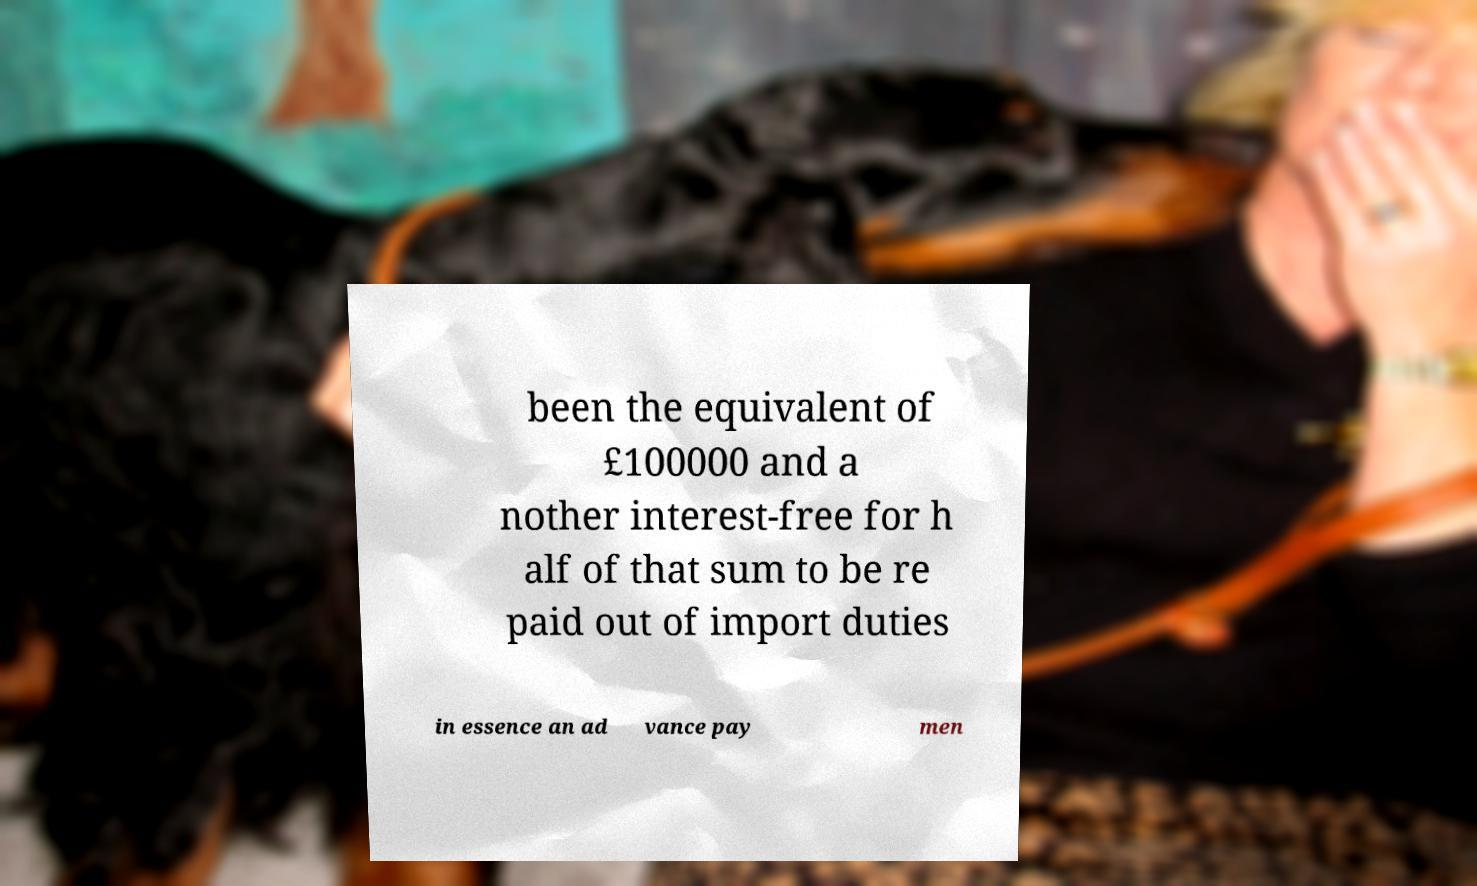Can you accurately transcribe the text from the provided image for me? been the equivalent of £100000 and a nother interest-free for h alf of that sum to be re paid out of import duties in essence an ad vance pay men 